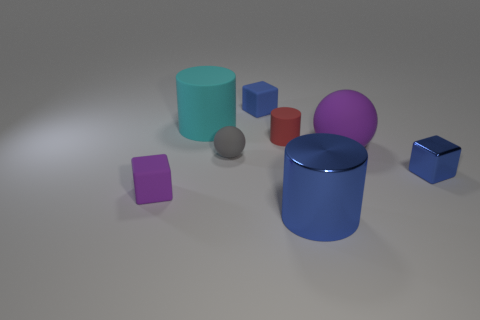How many objects are large spheres that are on the right side of the tiny red rubber thing or large rubber balls that are right of the gray rubber sphere?
Provide a succinct answer. 1. Are there an equal number of red objects to the left of the red matte thing and large rubber spheres that are in front of the large blue metallic object?
Provide a short and direct response. Yes. What is the shape of the tiny blue object that is right of the tiny matte cube that is behind the large cyan matte cylinder?
Provide a short and direct response. Cube. Is there a big cyan object that has the same shape as the tiny gray rubber object?
Your answer should be very brief. No. What number of big blue cylinders are there?
Give a very brief answer. 1. Are the tiny blue cube that is behind the cyan rubber cylinder and the large ball made of the same material?
Your answer should be very brief. Yes. Are there any blue shiny things of the same size as the blue matte object?
Your answer should be very brief. Yes. Does the tiny blue matte thing have the same shape as the large matte thing behind the tiny red thing?
Keep it short and to the point. No. There is a matte cube in front of the small rubber cube that is on the right side of the large cyan matte thing; are there any large spheres to the left of it?
Offer a very short reply. No. The red cylinder has what size?
Your response must be concise. Small. 